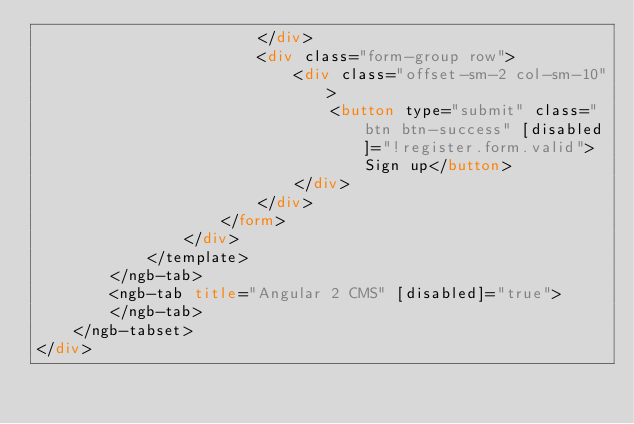Convert code to text. <code><loc_0><loc_0><loc_500><loc_500><_HTML_>                        </div>
                        <div class="form-group row">
                            <div class="offset-sm-2 col-sm-10">
                                <button type="submit" class="btn btn-success" [disabled]="!register.form.valid">Sign up</button>
                            </div>
                        </div>
                    </form>
                </div>
            </template>
        </ngb-tab>
        <ngb-tab title="Angular 2 CMS" [disabled]="true">
        </ngb-tab>
    </ngb-tabset>
</div></code> 